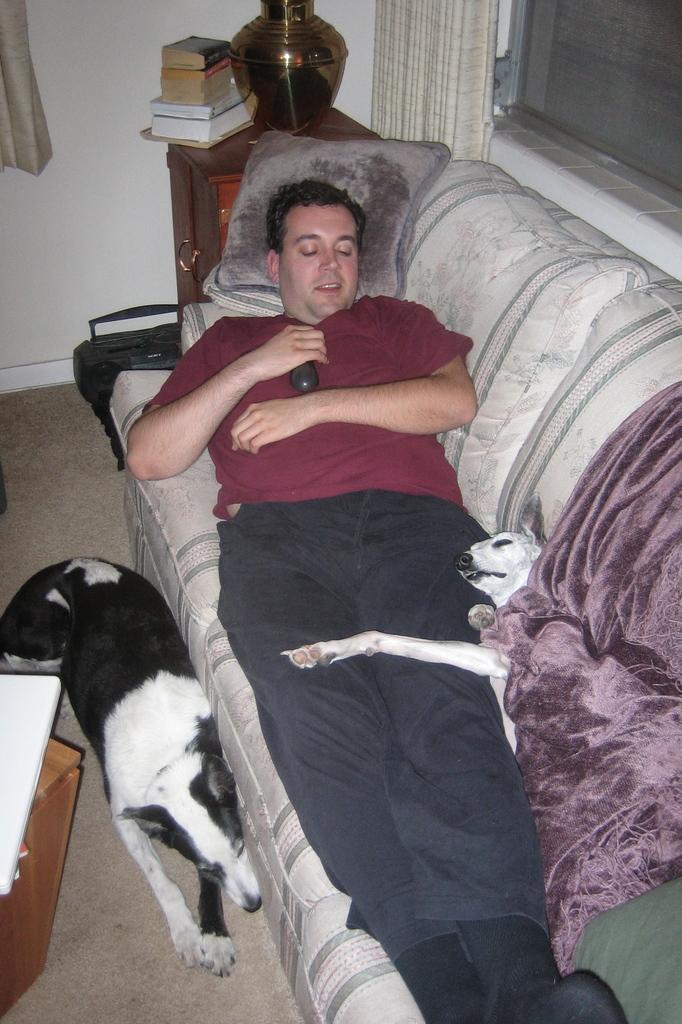Describe this image in one or two sentences. In the picture we can see a person(man) sleeping on the sofa with a pillow and dog, one dog is beside the sofa on a floor, in the background we can also see a table and on the table we can see some books and pot, and curtain beside the window. 